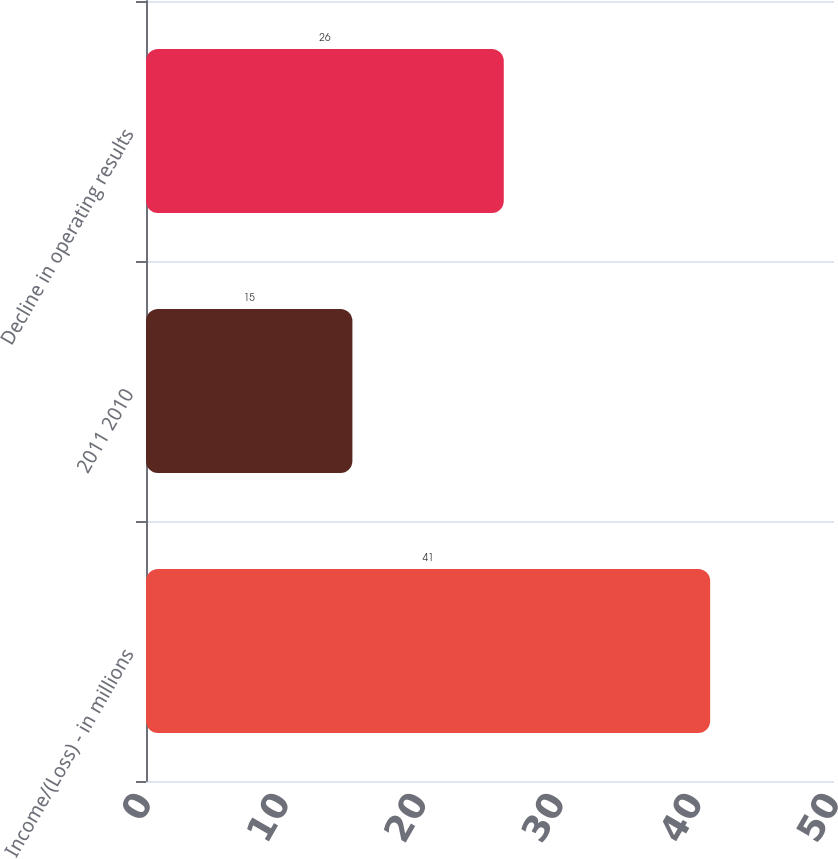<chart> <loc_0><loc_0><loc_500><loc_500><bar_chart><fcel>Income/(Loss) - in millions<fcel>2011 2010<fcel>Decline in operating results<nl><fcel>41<fcel>15<fcel>26<nl></chart> 